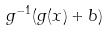Convert formula to latex. <formula><loc_0><loc_0><loc_500><loc_500>g ^ { - 1 } ( g ( x ) + b )</formula> 